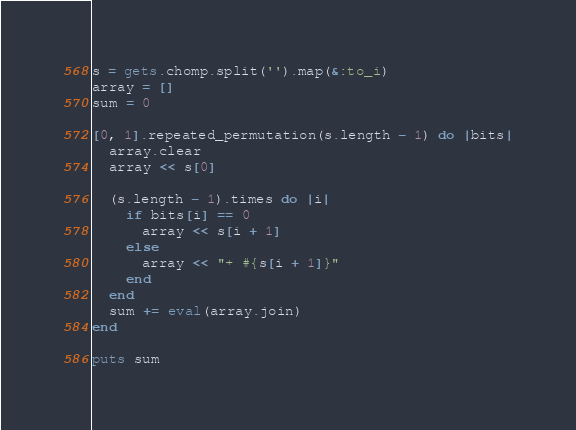<code> <loc_0><loc_0><loc_500><loc_500><_Ruby_>s = gets.chomp.split('').map(&:to_i)
array = []
sum = 0

[0, 1].repeated_permutation(s.length - 1) do |bits|
  array.clear
  array << s[0]
  
  (s.length - 1).times do |i|
    if bits[i] == 0
      array << s[i + 1]
    else
      array << "+ #{s[i + 1]}"
    end
  end
  sum += eval(array.join)
end

puts sum</code> 